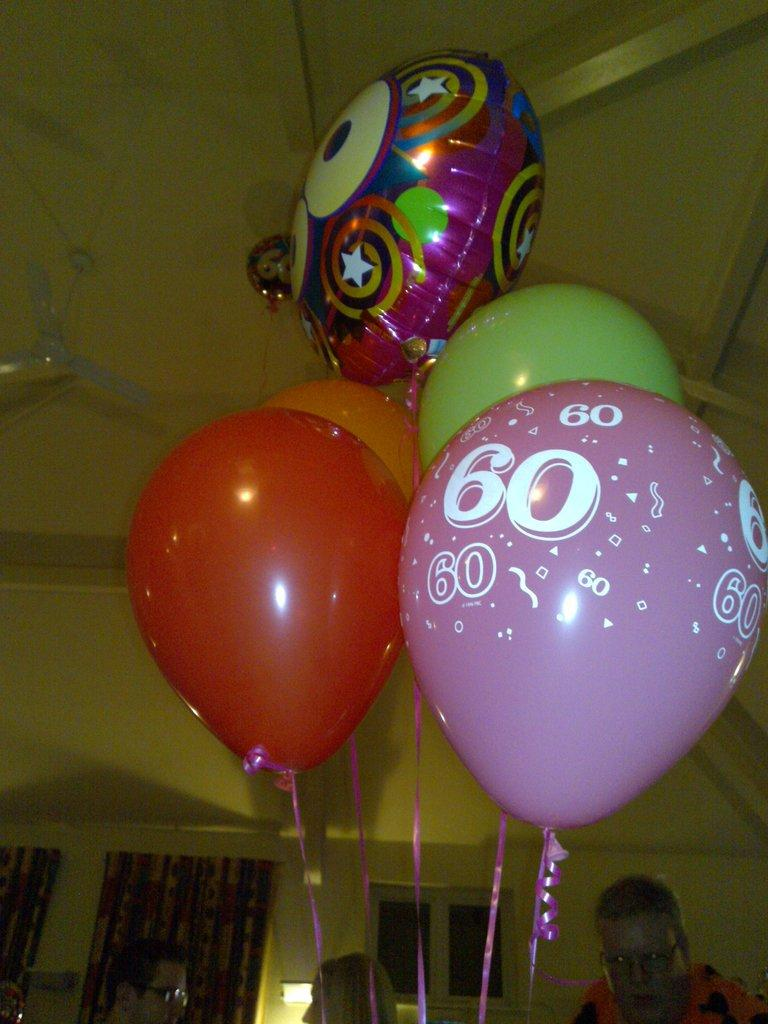What is tied with ribbons in the image? There is a group of balloons tied with ribbons in the image. Who is present in the image? There are people in the image. What can be seen on the wall in the image? There is a curtain in the image. What architectural feature is visible in the image? There is a window in the image. What type of lighting is present in the image? There is a light in the image, and there is also a ceiling light. What type of quarter is depicted on the flag in the image? There is no flag present in the image, so it is not possible to answer that question. Can you describe the swing in the image? There is no swing present in the image. 